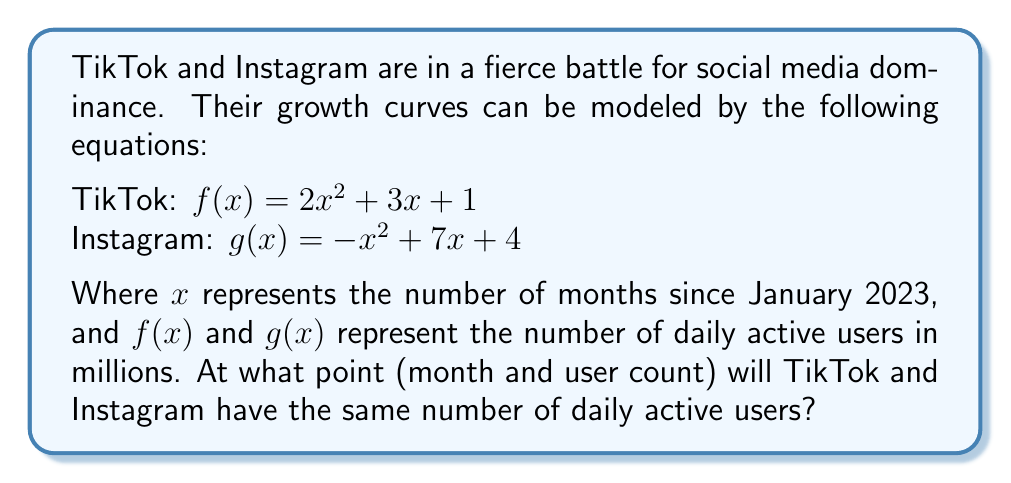Can you solve this math problem? Let's solve this step-by-step:

1) To find the intersection point, we need to set the two equations equal to each other:

   $f(x) = g(x)$
   $2x^2 + 3x + 1 = -x^2 + 7x + 4$

2) Rearrange the equation to standard form:

   $2x^2 + 3x + 1 + x^2 - 7x - 4 = 0$
   $3x^2 - 4x - 3 = 0$

3) This is a quadratic equation. We can solve it using the quadratic formula:
   $x = \frac{-b \pm \sqrt{b^2 - 4ac}}{2a}$

   Where $a = 3$, $b = -4$, and $c = -3$

4) Plugging these values into the quadratic formula:

   $x = \frac{4 \pm \sqrt{(-4)^2 - 4(3)(-3)}}{2(3)}$
   $x = \frac{4 \pm \sqrt{16 + 36}}{6}$
   $x = \frac{4 \pm \sqrt{52}}{6}$
   $x = \frac{4 \pm 7.21}{6}$

5) This gives us two solutions:
   $x_1 = \frac{4 + 7.21}{6} \approx 1.87$
   $x_2 = \frac{4 - 7.21}{6} \approx -0.54$

6) Since we're dealing with months since January 2023, we can discard the negative solution. The intersection occurs at approximately 1.87 months.

7) To find the number of users at this point, we can plug this x-value into either of the original equations. Let's use TikTok's equation:

   $f(1.87) = 2(1.87)^2 + 3(1.87) + 1$
   $f(1.87) \approx 7 + 5.61 + 1 = 13.61$

Therefore, the curves intersect at approximately 1.87 months after January 2023, with about 13.61 million daily active users.
Answer: (1.87, 13.61) 